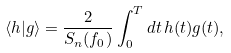<formula> <loc_0><loc_0><loc_500><loc_500>\left < h | g \right > = \frac { 2 } { S _ { n } ( f _ { 0 } ) } \int _ { 0 } ^ { T } d t \, h ( t ) g ( t ) ,</formula> 